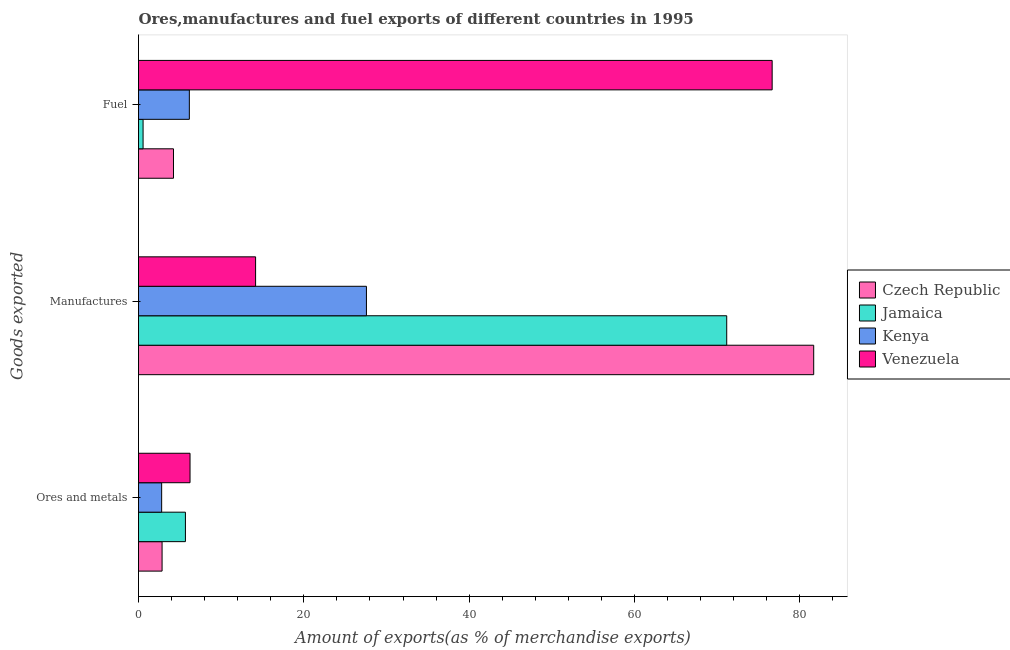How many different coloured bars are there?
Keep it short and to the point. 4. How many groups of bars are there?
Your answer should be compact. 3. How many bars are there on the 1st tick from the bottom?
Offer a very short reply. 4. What is the label of the 3rd group of bars from the top?
Give a very brief answer. Ores and metals. What is the percentage of ores and metals exports in Kenya?
Your answer should be very brief. 2.8. Across all countries, what is the maximum percentage of ores and metals exports?
Provide a short and direct response. 6.23. Across all countries, what is the minimum percentage of fuel exports?
Ensure brevity in your answer.  0.55. In which country was the percentage of ores and metals exports maximum?
Your answer should be very brief. Venezuela. In which country was the percentage of fuel exports minimum?
Provide a short and direct response. Jamaica. What is the total percentage of fuel exports in the graph?
Your answer should be very brief. 87.58. What is the difference between the percentage of fuel exports in Venezuela and that in Czech Republic?
Offer a terse response. 72.42. What is the difference between the percentage of ores and metals exports in Jamaica and the percentage of manufactures exports in Venezuela?
Offer a very short reply. -8.49. What is the average percentage of ores and metals exports per country?
Offer a terse response. 4.39. What is the difference between the percentage of ores and metals exports and percentage of fuel exports in Kenya?
Provide a succinct answer. -3.35. In how many countries, is the percentage of fuel exports greater than 36 %?
Offer a terse response. 1. What is the ratio of the percentage of ores and metals exports in Czech Republic to that in Jamaica?
Keep it short and to the point. 0.5. What is the difference between the highest and the second highest percentage of manufactures exports?
Provide a succinct answer. 10.52. What is the difference between the highest and the lowest percentage of manufactures exports?
Give a very brief answer. 67.51. What does the 1st bar from the top in Fuel represents?
Your answer should be very brief. Venezuela. What does the 1st bar from the bottom in Ores and metals represents?
Ensure brevity in your answer.  Czech Republic. Are all the bars in the graph horizontal?
Ensure brevity in your answer.  Yes. Are the values on the major ticks of X-axis written in scientific E-notation?
Your response must be concise. No. Does the graph contain grids?
Provide a succinct answer. No. How many legend labels are there?
Make the answer very short. 4. How are the legend labels stacked?
Offer a terse response. Vertical. What is the title of the graph?
Your answer should be compact. Ores,manufactures and fuel exports of different countries in 1995. What is the label or title of the X-axis?
Give a very brief answer. Amount of exports(as % of merchandise exports). What is the label or title of the Y-axis?
Offer a terse response. Goods exported. What is the Amount of exports(as % of merchandise exports) of Czech Republic in Ores and metals?
Ensure brevity in your answer.  2.85. What is the Amount of exports(as % of merchandise exports) in Jamaica in Ores and metals?
Make the answer very short. 5.67. What is the Amount of exports(as % of merchandise exports) of Kenya in Ores and metals?
Your response must be concise. 2.8. What is the Amount of exports(as % of merchandise exports) of Venezuela in Ores and metals?
Your response must be concise. 6.23. What is the Amount of exports(as % of merchandise exports) in Czech Republic in Manufactures?
Your answer should be very brief. 81.68. What is the Amount of exports(as % of merchandise exports) of Jamaica in Manufactures?
Offer a very short reply. 71.15. What is the Amount of exports(as % of merchandise exports) in Kenya in Manufactures?
Your answer should be very brief. 27.57. What is the Amount of exports(as % of merchandise exports) of Venezuela in Manufactures?
Keep it short and to the point. 14.16. What is the Amount of exports(as % of merchandise exports) in Czech Republic in Fuel?
Offer a terse response. 4.23. What is the Amount of exports(as % of merchandise exports) in Jamaica in Fuel?
Provide a short and direct response. 0.55. What is the Amount of exports(as % of merchandise exports) in Kenya in Fuel?
Your answer should be very brief. 6.15. What is the Amount of exports(as % of merchandise exports) of Venezuela in Fuel?
Offer a very short reply. 76.65. Across all Goods exported, what is the maximum Amount of exports(as % of merchandise exports) of Czech Republic?
Make the answer very short. 81.68. Across all Goods exported, what is the maximum Amount of exports(as % of merchandise exports) in Jamaica?
Make the answer very short. 71.15. Across all Goods exported, what is the maximum Amount of exports(as % of merchandise exports) in Kenya?
Your response must be concise. 27.57. Across all Goods exported, what is the maximum Amount of exports(as % of merchandise exports) of Venezuela?
Your answer should be very brief. 76.65. Across all Goods exported, what is the minimum Amount of exports(as % of merchandise exports) of Czech Republic?
Make the answer very short. 2.85. Across all Goods exported, what is the minimum Amount of exports(as % of merchandise exports) in Jamaica?
Your answer should be compact. 0.55. Across all Goods exported, what is the minimum Amount of exports(as % of merchandise exports) of Kenya?
Your answer should be very brief. 2.8. Across all Goods exported, what is the minimum Amount of exports(as % of merchandise exports) of Venezuela?
Keep it short and to the point. 6.23. What is the total Amount of exports(as % of merchandise exports) in Czech Republic in the graph?
Provide a succinct answer. 88.76. What is the total Amount of exports(as % of merchandise exports) in Jamaica in the graph?
Give a very brief answer. 77.38. What is the total Amount of exports(as % of merchandise exports) in Kenya in the graph?
Make the answer very short. 36.52. What is the total Amount of exports(as % of merchandise exports) of Venezuela in the graph?
Your response must be concise. 97.05. What is the difference between the Amount of exports(as % of merchandise exports) of Czech Republic in Ores and metals and that in Manufactures?
Provide a succinct answer. -78.83. What is the difference between the Amount of exports(as % of merchandise exports) in Jamaica in Ores and metals and that in Manufactures?
Provide a succinct answer. -65.48. What is the difference between the Amount of exports(as % of merchandise exports) of Kenya in Ores and metals and that in Manufactures?
Your answer should be compact. -24.77. What is the difference between the Amount of exports(as % of merchandise exports) in Venezuela in Ores and metals and that in Manufactures?
Make the answer very short. -7.93. What is the difference between the Amount of exports(as % of merchandise exports) in Czech Republic in Ores and metals and that in Fuel?
Provide a short and direct response. -1.38. What is the difference between the Amount of exports(as % of merchandise exports) in Jamaica in Ores and metals and that in Fuel?
Provide a succinct answer. 5.12. What is the difference between the Amount of exports(as % of merchandise exports) in Kenya in Ores and metals and that in Fuel?
Ensure brevity in your answer.  -3.35. What is the difference between the Amount of exports(as % of merchandise exports) of Venezuela in Ores and metals and that in Fuel?
Offer a very short reply. -70.42. What is the difference between the Amount of exports(as % of merchandise exports) of Czech Republic in Manufactures and that in Fuel?
Give a very brief answer. 77.45. What is the difference between the Amount of exports(as % of merchandise exports) in Jamaica in Manufactures and that in Fuel?
Your response must be concise. 70.6. What is the difference between the Amount of exports(as % of merchandise exports) of Kenya in Manufactures and that in Fuel?
Provide a succinct answer. 21.42. What is the difference between the Amount of exports(as % of merchandise exports) of Venezuela in Manufactures and that in Fuel?
Your answer should be very brief. -62.49. What is the difference between the Amount of exports(as % of merchandise exports) in Czech Republic in Ores and metals and the Amount of exports(as % of merchandise exports) in Jamaica in Manufactures?
Your answer should be very brief. -68.3. What is the difference between the Amount of exports(as % of merchandise exports) in Czech Republic in Ores and metals and the Amount of exports(as % of merchandise exports) in Kenya in Manufactures?
Give a very brief answer. -24.72. What is the difference between the Amount of exports(as % of merchandise exports) of Czech Republic in Ores and metals and the Amount of exports(as % of merchandise exports) of Venezuela in Manufactures?
Keep it short and to the point. -11.31. What is the difference between the Amount of exports(as % of merchandise exports) of Jamaica in Ores and metals and the Amount of exports(as % of merchandise exports) of Kenya in Manufactures?
Make the answer very short. -21.9. What is the difference between the Amount of exports(as % of merchandise exports) in Jamaica in Ores and metals and the Amount of exports(as % of merchandise exports) in Venezuela in Manufactures?
Keep it short and to the point. -8.49. What is the difference between the Amount of exports(as % of merchandise exports) in Kenya in Ores and metals and the Amount of exports(as % of merchandise exports) in Venezuela in Manufactures?
Provide a short and direct response. -11.36. What is the difference between the Amount of exports(as % of merchandise exports) of Czech Republic in Ores and metals and the Amount of exports(as % of merchandise exports) of Jamaica in Fuel?
Keep it short and to the point. 2.3. What is the difference between the Amount of exports(as % of merchandise exports) in Czech Republic in Ores and metals and the Amount of exports(as % of merchandise exports) in Kenya in Fuel?
Your answer should be compact. -3.3. What is the difference between the Amount of exports(as % of merchandise exports) in Czech Republic in Ores and metals and the Amount of exports(as % of merchandise exports) in Venezuela in Fuel?
Your answer should be compact. -73.8. What is the difference between the Amount of exports(as % of merchandise exports) of Jamaica in Ores and metals and the Amount of exports(as % of merchandise exports) of Kenya in Fuel?
Provide a succinct answer. -0.48. What is the difference between the Amount of exports(as % of merchandise exports) of Jamaica in Ores and metals and the Amount of exports(as % of merchandise exports) of Venezuela in Fuel?
Provide a succinct answer. -70.98. What is the difference between the Amount of exports(as % of merchandise exports) of Kenya in Ores and metals and the Amount of exports(as % of merchandise exports) of Venezuela in Fuel?
Provide a short and direct response. -73.85. What is the difference between the Amount of exports(as % of merchandise exports) of Czech Republic in Manufactures and the Amount of exports(as % of merchandise exports) of Jamaica in Fuel?
Give a very brief answer. 81.12. What is the difference between the Amount of exports(as % of merchandise exports) of Czech Republic in Manufactures and the Amount of exports(as % of merchandise exports) of Kenya in Fuel?
Keep it short and to the point. 75.53. What is the difference between the Amount of exports(as % of merchandise exports) in Czech Republic in Manufactures and the Amount of exports(as % of merchandise exports) in Venezuela in Fuel?
Your response must be concise. 5.03. What is the difference between the Amount of exports(as % of merchandise exports) in Jamaica in Manufactures and the Amount of exports(as % of merchandise exports) in Kenya in Fuel?
Make the answer very short. 65. What is the difference between the Amount of exports(as % of merchandise exports) of Jamaica in Manufactures and the Amount of exports(as % of merchandise exports) of Venezuela in Fuel?
Offer a very short reply. -5.5. What is the difference between the Amount of exports(as % of merchandise exports) in Kenya in Manufactures and the Amount of exports(as % of merchandise exports) in Venezuela in Fuel?
Your response must be concise. -49.08. What is the average Amount of exports(as % of merchandise exports) of Czech Republic per Goods exported?
Keep it short and to the point. 29.59. What is the average Amount of exports(as % of merchandise exports) in Jamaica per Goods exported?
Make the answer very short. 25.79. What is the average Amount of exports(as % of merchandise exports) in Kenya per Goods exported?
Keep it short and to the point. 12.17. What is the average Amount of exports(as % of merchandise exports) of Venezuela per Goods exported?
Give a very brief answer. 32.35. What is the difference between the Amount of exports(as % of merchandise exports) of Czech Republic and Amount of exports(as % of merchandise exports) of Jamaica in Ores and metals?
Ensure brevity in your answer.  -2.82. What is the difference between the Amount of exports(as % of merchandise exports) in Czech Republic and Amount of exports(as % of merchandise exports) in Kenya in Ores and metals?
Offer a terse response. 0.05. What is the difference between the Amount of exports(as % of merchandise exports) of Czech Republic and Amount of exports(as % of merchandise exports) of Venezuela in Ores and metals?
Give a very brief answer. -3.38. What is the difference between the Amount of exports(as % of merchandise exports) of Jamaica and Amount of exports(as % of merchandise exports) of Kenya in Ores and metals?
Provide a short and direct response. 2.87. What is the difference between the Amount of exports(as % of merchandise exports) in Jamaica and Amount of exports(as % of merchandise exports) in Venezuela in Ores and metals?
Ensure brevity in your answer.  -0.56. What is the difference between the Amount of exports(as % of merchandise exports) of Kenya and Amount of exports(as % of merchandise exports) of Venezuela in Ores and metals?
Your answer should be very brief. -3.43. What is the difference between the Amount of exports(as % of merchandise exports) of Czech Republic and Amount of exports(as % of merchandise exports) of Jamaica in Manufactures?
Provide a succinct answer. 10.52. What is the difference between the Amount of exports(as % of merchandise exports) in Czech Republic and Amount of exports(as % of merchandise exports) in Kenya in Manufactures?
Your answer should be compact. 54.11. What is the difference between the Amount of exports(as % of merchandise exports) in Czech Republic and Amount of exports(as % of merchandise exports) in Venezuela in Manufactures?
Your answer should be compact. 67.51. What is the difference between the Amount of exports(as % of merchandise exports) in Jamaica and Amount of exports(as % of merchandise exports) in Kenya in Manufactures?
Provide a short and direct response. 43.58. What is the difference between the Amount of exports(as % of merchandise exports) of Jamaica and Amount of exports(as % of merchandise exports) of Venezuela in Manufactures?
Make the answer very short. 56.99. What is the difference between the Amount of exports(as % of merchandise exports) in Kenya and Amount of exports(as % of merchandise exports) in Venezuela in Manufactures?
Keep it short and to the point. 13.41. What is the difference between the Amount of exports(as % of merchandise exports) in Czech Republic and Amount of exports(as % of merchandise exports) in Jamaica in Fuel?
Your answer should be very brief. 3.68. What is the difference between the Amount of exports(as % of merchandise exports) in Czech Republic and Amount of exports(as % of merchandise exports) in Kenya in Fuel?
Provide a succinct answer. -1.92. What is the difference between the Amount of exports(as % of merchandise exports) of Czech Republic and Amount of exports(as % of merchandise exports) of Venezuela in Fuel?
Offer a terse response. -72.42. What is the difference between the Amount of exports(as % of merchandise exports) of Jamaica and Amount of exports(as % of merchandise exports) of Kenya in Fuel?
Ensure brevity in your answer.  -5.6. What is the difference between the Amount of exports(as % of merchandise exports) of Jamaica and Amount of exports(as % of merchandise exports) of Venezuela in Fuel?
Make the answer very short. -76.1. What is the difference between the Amount of exports(as % of merchandise exports) of Kenya and Amount of exports(as % of merchandise exports) of Venezuela in Fuel?
Ensure brevity in your answer.  -70.5. What is the ratio of the Amount of exports(as % of merchandise exports) of Czech Republic in Ores and metals to that in Manufactures?
Make the answer very short. 0.03. What is the ratio of the Amount of exports(as % of merchandise exports) in Jamaica in Ores and metals to that in Manufactures?
Your response must be concise. 0.08. What is the ratio of the Amount of exports(as % of merchandise exports) in Kenya in Ores and metals to that in Manufactures?
Offer a terse response. 0.1. What is the ratio of the Amount of exports(as % of merchandise exports) of Venezuela in Ores and metals to that in Manufactures?
Your answer should be compact. 0.44. What is the ratio of the Amount of exports(as % of merchandise exports) in Czech Republic in Ores and metals to that in Fuel?
Ensure brevity in your answer.  0.67. What is the ratio of the Amount of exports(as % of merchandise exports) of Jamaica in Ores and metals to that in Fuel?
Make the answer very short. 10.26. What is the ratio of the Amount of exports(as % of merchandise exports) in Kenya in Ores and metals to that in Fuel?
Offer a very short reply. 0.46. What is the ratio of the Amount of exports(as % of merchandise exports) in Venezuela in Ores and metals to that in Fuel?
Your answer should be compact. 0.08. What is the ratio of the Amount of exports(as % of merchandise exports) in Czech Republic in Manufactures to that in Fuel?
Your answer should be very brief. 19.3. What is the ratio of the Amount of exports(as % of merchandise exports) in Jamaica in Manufactures to that in Fuel?
Your answer should be very brief. 128.68. What is the ratio of the Amount of exports(as % of merchandise exports) in Kenya in Manufactures to that in Fuel?
Your response must be concise. 4.48. What is the ratio of the Amount of exports(as % of merchandise exports) in Venezuela in Manufactures to that in Fuel?
Provide a short and direct response. 0.18. What is the difference between the highest and the second highest Amount of exports(as % of merchandise exports) of Czech Republic?
Keep it short and to the point. 77.45. What is the difference between the highest and the second highest Amount of exports(as % of merchandise exports) in Jamaica?
Your answer should be compact. 65.48. What is the difference between the highest and the second highest Amount of exports(as % of merchandise exports) of Kenya?
Ensure brevity in your answer.  21.42. What is the difference between the highest and the second highest Amount of exports(as % of merchandise exports) of Venezuela?
Provide a succinct answer. 62.49. What is the difference between the highest and the lowest Amount of exports(as % of merchandise exports) of Czech Republic?
Your answer should be very brief. 78.83. What is the difference between the highest and the lowest Amount of exports(as % of merchandise exports) in Jamaica?
Your answer should be compact. 70.6. What is the difference between the highest and the lowest Amount of exports(as % of merchandise exports) of Kenya?
Offer a terse response. 24.77. What is the difference between the highest and the lowest Amount of exports(as % of merchandise exports) of Venezuela?
Your answer should be compact. 70.42. 